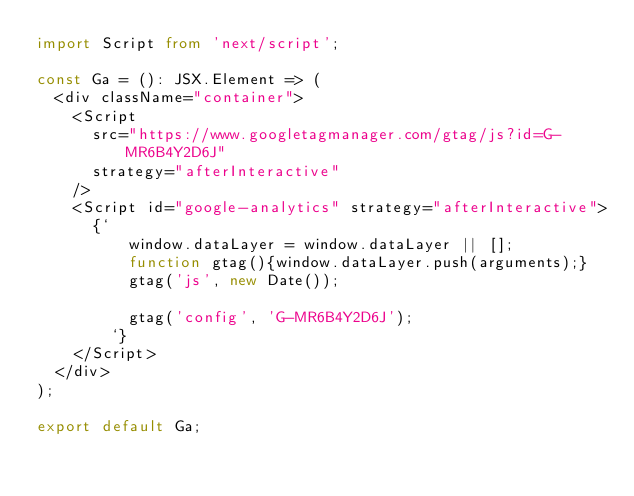Convert code to text. <code><loc_0><loc_0><loc_500><loc_500><_TypeScript_>import Script from 'next/script';

const Ga = (): JSX.Element => (
  <div className="container">
    <Script
      src="https://www.googletagmanager.com/gtag/js?id=G-MR6B4Y2D6J"
      strategy="afterInteractive"
    />
    <Script id="google-analytics" strategy="afterInteractive">
      {`
          window.dataLayer = window.dataLayer || [];
          function gtag(){window.dataLayer.push(arguments);}
          gtag('js', new Date());

          gtag('config', 'G-MR6B4Y2D6J');
        `}
    </Script>
  </div>
);

export default Ga;
</code> 